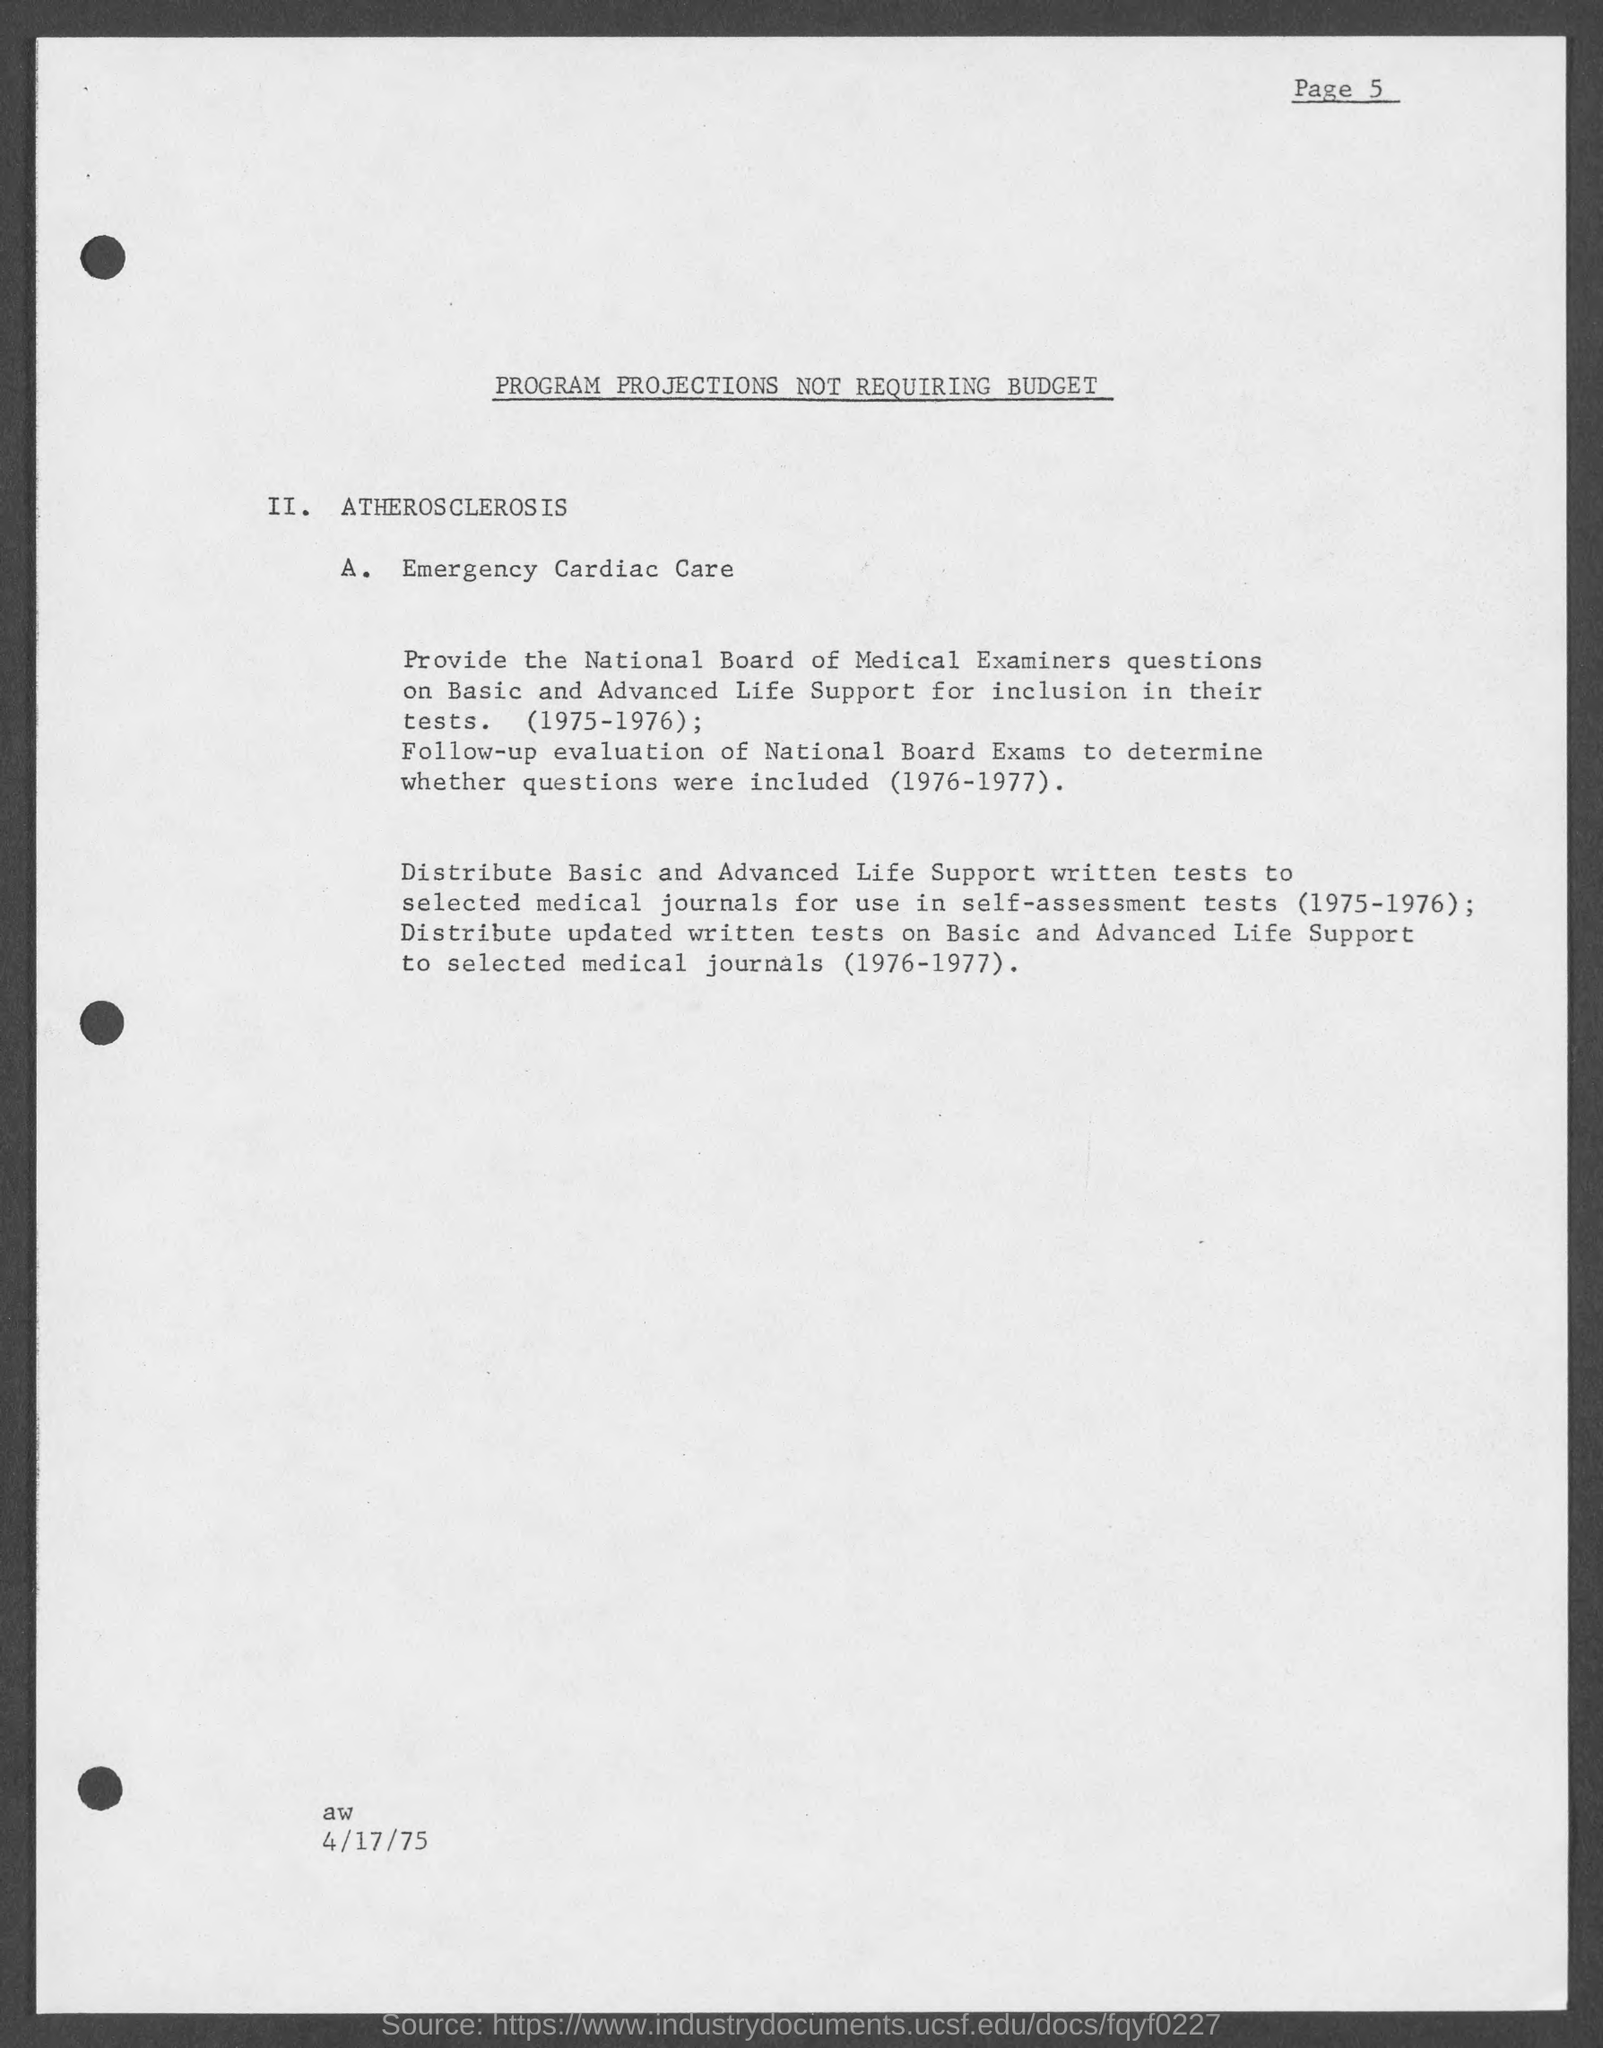Outline some significant characteristics in this image. The document is dated as of April 17, 1975. The title of the document is 'PROGRAM PROJECTIONS NOT REQUIRING BUDGET'. What is Point A.? It refers to Emergency Cardiac Care. The page number on this document is 5, as declared. 